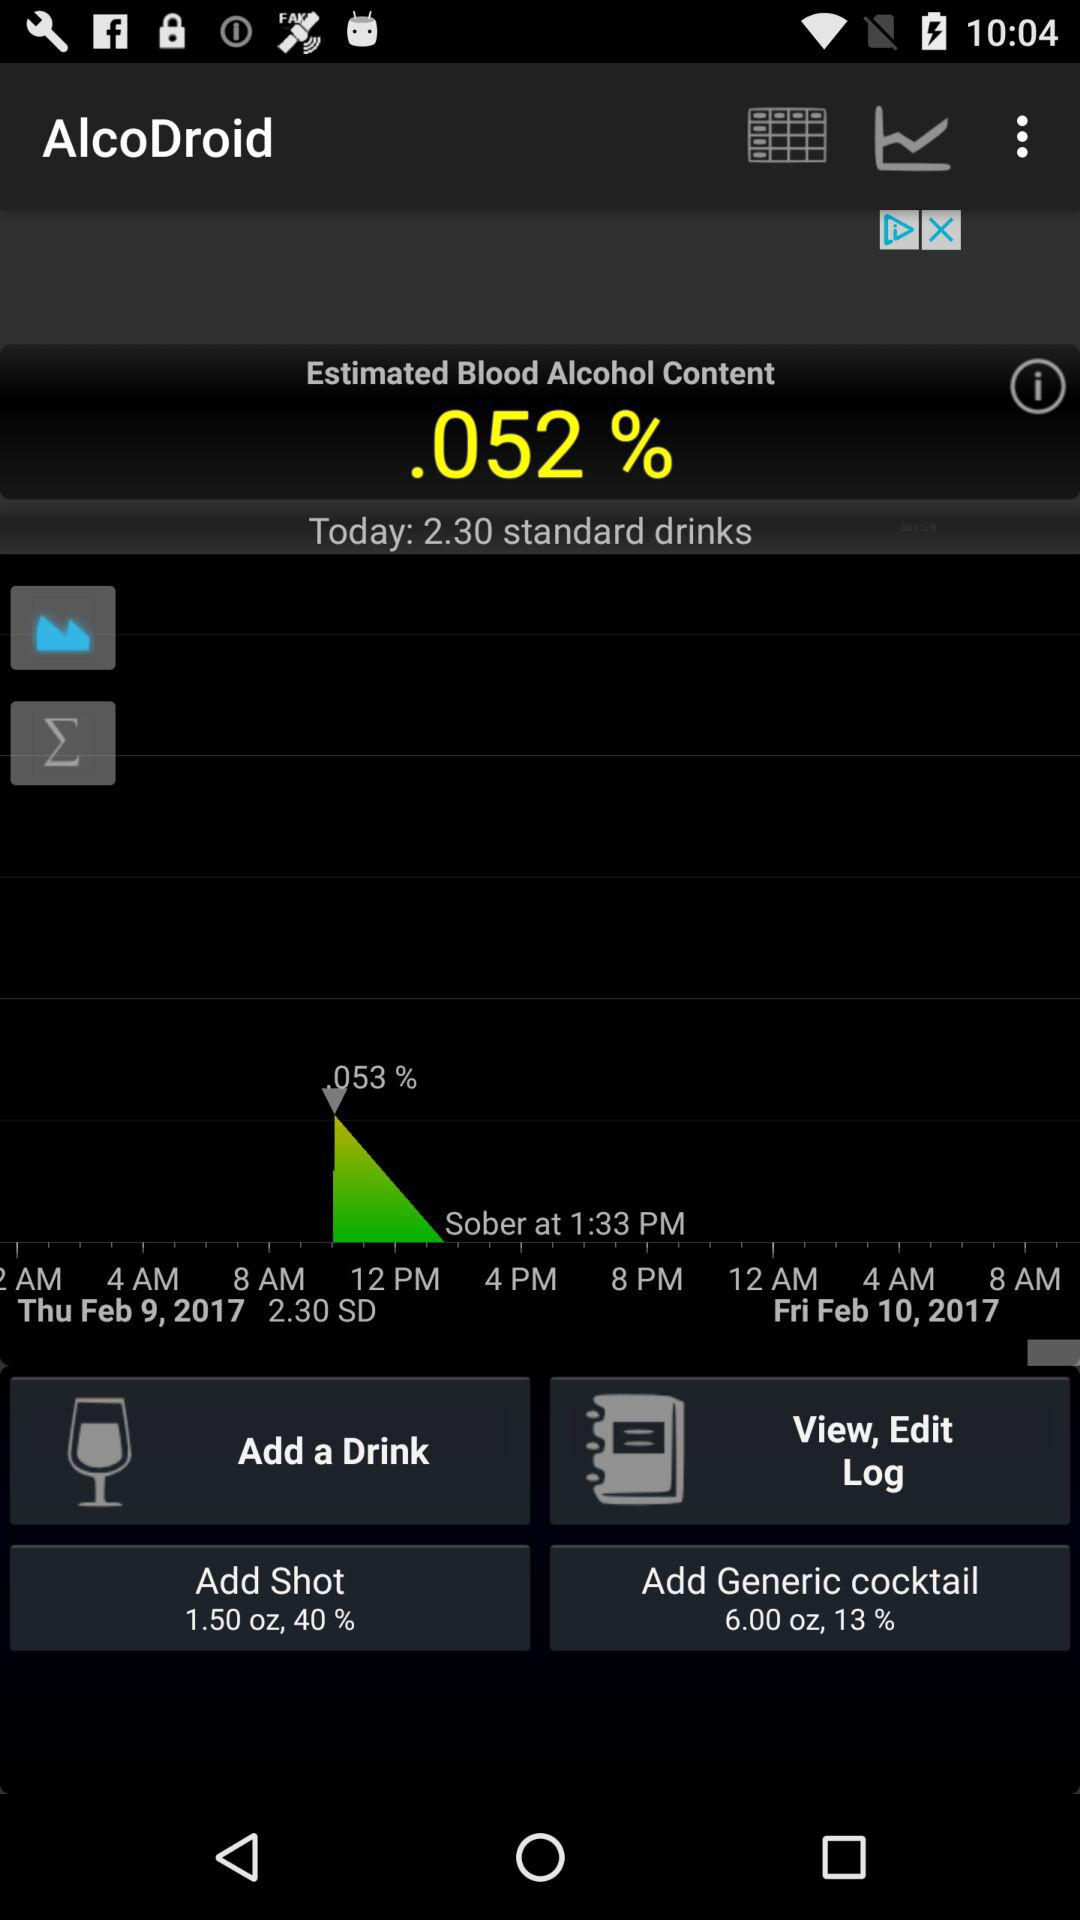What is the blood alcohol percentage? The blood alcohol percentage is 0.052. 